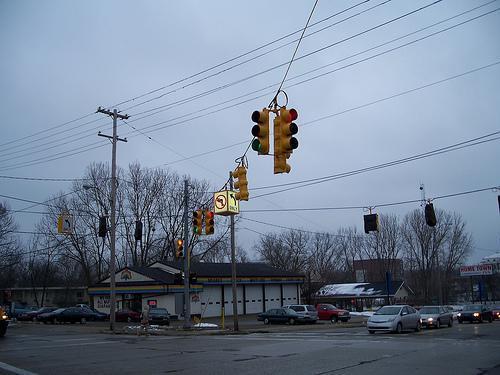How many doors are on the garage?
Give a very brief answer. 5. How many traffic lights are visible?
Give a very brief answer. 9. How many cars have headlights on?
Give a very brief answer. 3. How many stories is the building on the corner?
Give a very brief answer. 1. 